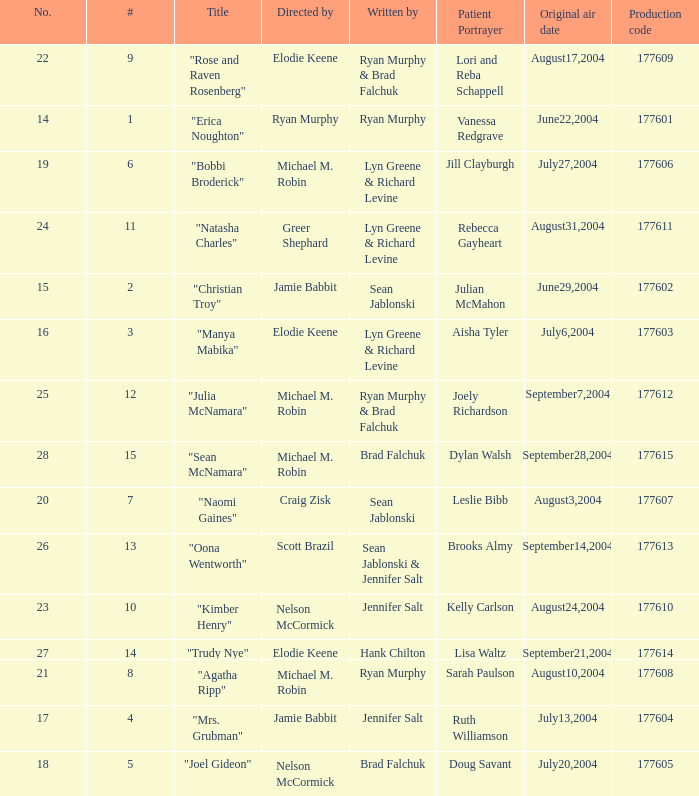How many episodes are numbered 4 in the season? 1.0. 